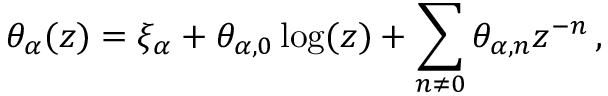Convert formula to latex. <formula><loc_0><loc_0><loc_500><loc_500>\theta _ { \alpha } ( z ) = \xi _ { \alpha } + \theta _ { \alpha , 0 } \log ( z ) + \sum _ { n \neq 0 } \theta _ { \alpha , n } z ^ { - n } \, ,</formula> 